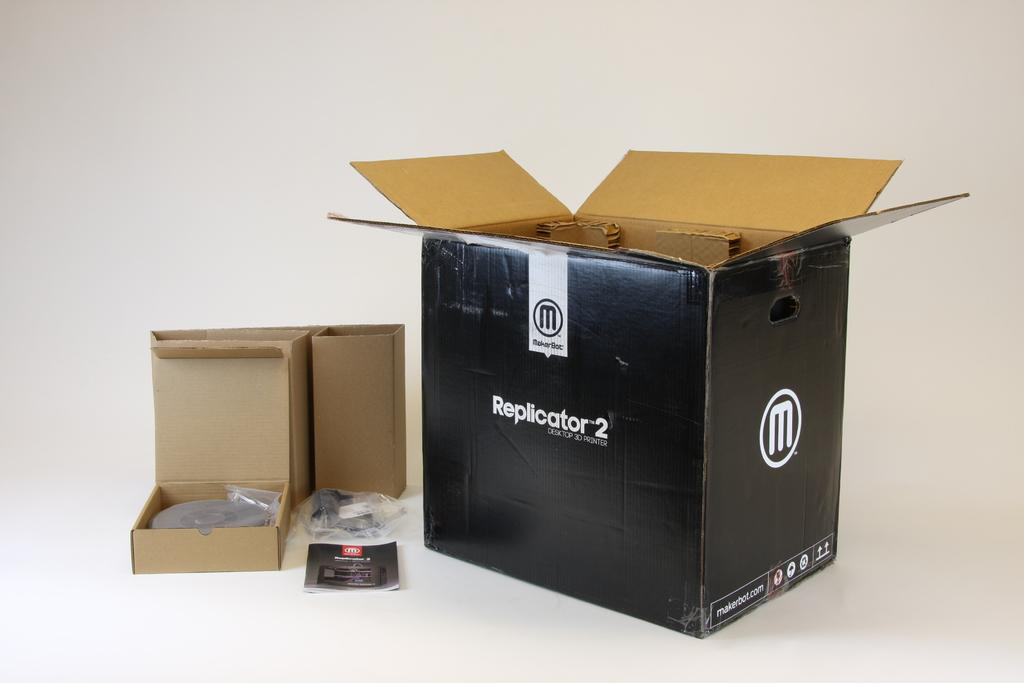<image>
Offer a succinct explanation of the picture presented. An open Replicator 2 box sits next to its contents. 